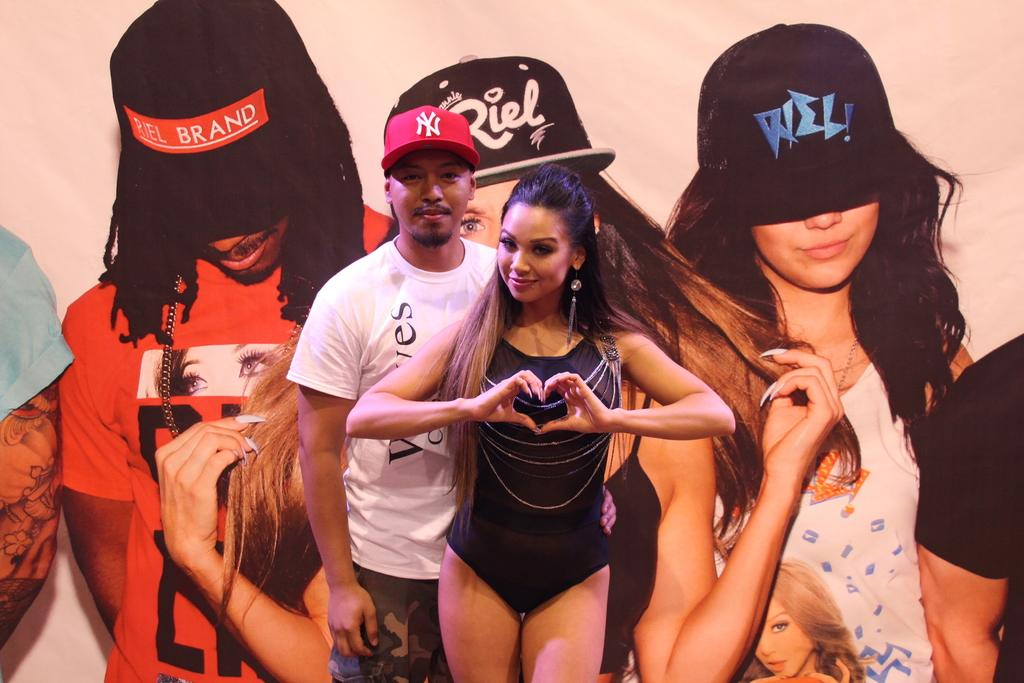Provide a one-sentence caption for the provided image. a man wearing a NY hat standing next to a young woman. 